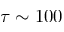Convert formula to latex. <formula><loc_0><loc_0><loc_500><loc_500>\tau \sim 1 0 0</formula> 